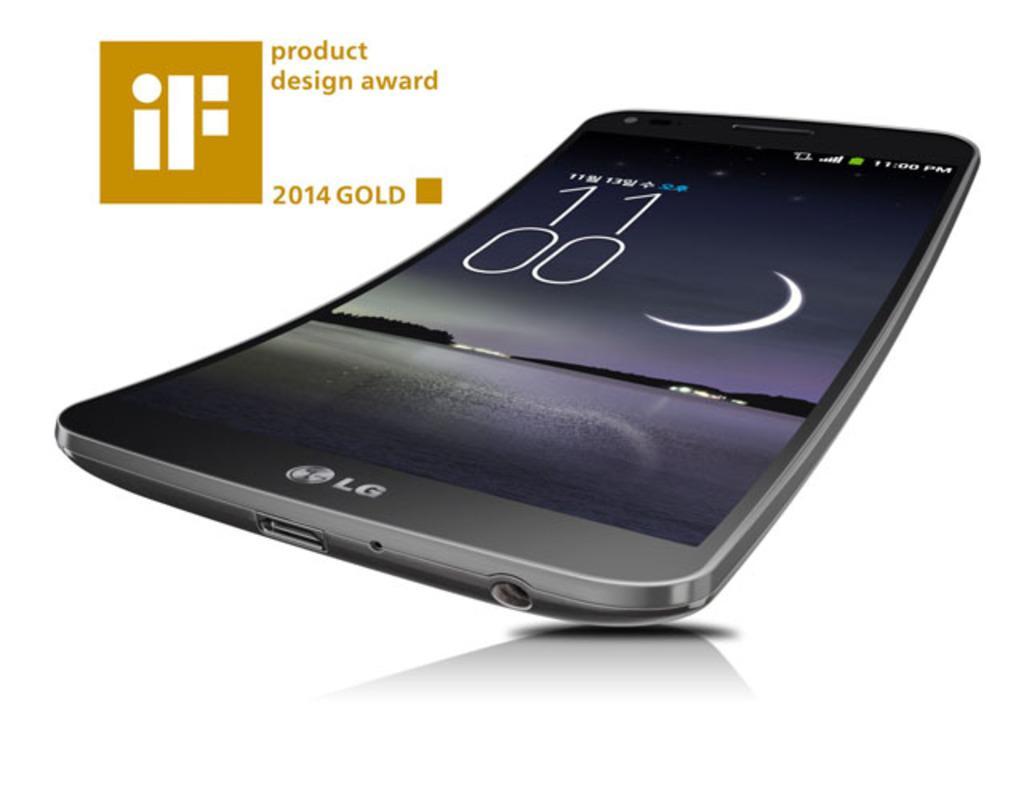Please provide a concise description of this image. In this image there is a mobile phone. There is text on the mobile phone. Beside the text there is a logo. On the display screen there are numbers and pictures. There are pictures of trees, water, sky and a moon in the sky. Beside the phone there are numbers, text and a logo. The background is white. 